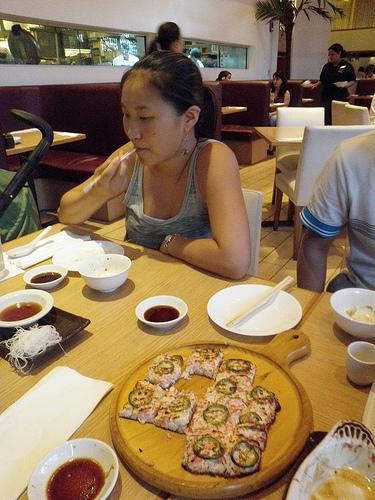In which style are the food dishes arranged on the table? Asian style food spread on two tables pushed together. What is the profession of the person serving food to the diners? A waiter is serving food to the people sitting in the booth. Identify the type of food on the wooden tray. Pizza is on a wood board. Briefly explain the appearance of the noodles on the corner of the plate. White noodles on a black dish. Express in a few words the action that the woman is performing. Woman eating with chopsticks. Where can you find soy sauce in the image? Soy sauce is in a small bowl. What is the woman wearing on her wrist? The woman is wearing a watch on her wrist. What kind of utensil does the woman have in her hands? The woman is holding chopsticks. Mention a noticeable accessory worn by the woman. The woman is wearing earrings. Point out the color of the liquid in the small white bowl on the table. The liquid in the small white bowl is dark red. 